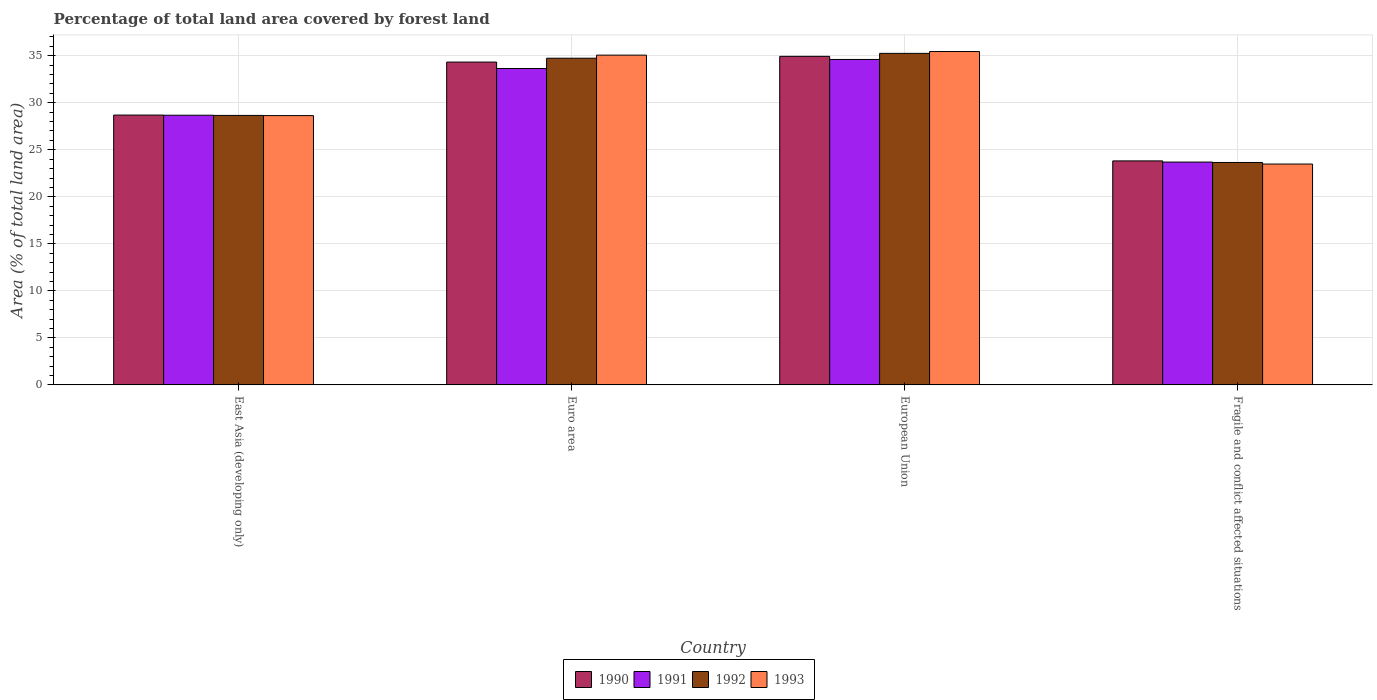How many different coloured bars are there?
Give a very brief answer. 4. Are the number of bars on each tick of the X-axis equal?
Make the answer very short. Yes. How many bars are there on the 3rd tick from the left?
Keep it short and to the point. 4. What is the label of the 3rd group of bars from the left?
Keep it short and to the point. European Union. What is the percentage of forest land in 1991 in European Union?
Make the answer very short. 34.6. Across all countries, what is the maximum percentage of forest land in 1993?
Keep it short and to the point. 35.45. Across all countries, what is the minimum percentage of forest land in 1993?
Provide a short and direct response. 23.48. In which country was the percentage of forest land in 1992 maximum?
Provide a succinct answer. European Union. In which country was the percentage of forest land in 1990 minimum?
Offer a very short reply. Fragile and conflict affected situations. What is the total percentage of forest land in 1990 in the graph?
Offer a very short reply. 121.77. What is the difference between the percentage of forest land in 1990 in East Asia (developing only) and that in European Union?
Offer a terse response. -6.24. What is the difference between the percentage of forest land in 1993 in Fragile and conflict affected situations and the percentage of forest land in 1992 in European Union?
Keep it short and to the point. -11.77. What is the average percentage of forest land in 1991 per country?
Keep it short and to the point. 30.15. What is the difference between the percentage of forest land of/in 1993 and percentage of forest land of/in 1992 in Fragile and conflict affected situations?
Ensure brevity in your answer.  -0.17. In how many countries, is the percentage of forest land in 1992 greater than 31 %?
Provide a succinct answer. 2. What is the ratio of the percentage of forest land in 1990 in East Asia (developing only) to that in Euro area?
Offer a very short reply. 0.84. Is the percentage of forest land in 1993 in Euro area less than that in Fragile and conflict affected situations?
Your response must be concise. No. What is the difference between the highest and the second highest percentage of forest land in 1990?
Offer a very short reply. 0.61. What is the difference between the highest and the lowest percentage of forest land in 1990?
Your answer should be compact. 11.12. What does the 4th bar from the left in European Union represents?
Provide a short and direct response. 1993. Are all the bars in the graph horizontal?
Offer a terse response. No. What is the difference between two consecutive major ticks on the Y-axis?
Provide a short and direct response. 5. Are the values on the major ticks of Y-axis written in scientific E-notation?
Keep it short and to the point. No. Does the graph contain any zero values?
Provide a short and direct response. No. Does the graph contain grids?
Your response must be concise. Yes. How are the legend labels stacked?
Provide a short and direct response. Horizontal. What is the title of the graph?
Provide a short and direct response. Percentage of total land area covered by forest land. Does "2001" appear as one of the legend labels in the graph?
Your response must be concise. No. What is the label or title of the Y-axis?
Give a very brief answer. Area (% of total land area). What is the Area (% of total land area) in 1990 in East Asia (developing only)?
Your answer should be compact. 28.69. What is the Area (% of total land area) of 1991 in East Asia (developing only)?
Offer a very short reply. 28.68. What is the Area (% of total land area) of 1992 in East Asia (developing only)?
Offer a very short reply. 28.65. What is the Area (% of total land area) of 1993 in East Asia (developing only)?
Offer a very short reply. 28.63. What is the Area (% of total land area) in 1990 in Euro area?
Offer a terse response. 34.33. What is the Area (% of total land area) in 1991 in Euro area?
Your answer should be very brief. 33.64. What is the Area (% of total land area) of 1992 in Euro area?
Keep it short and to the point. 34.74. What is the Area (% of total land area) in 1993 in Euro area?
Your answer should be very brief. 35.06. What is the Area (% of total land area) in 1990 in European Union?
Your answer should be very brief. 34.93. What is the Area (% of total land area) in 1991 in European Union?
Keep it short and to the point. 34.6. What is the Area (% of total land area) of 1992 in European Union?
Your answer should be compact. 35.25. What is the Area (% of total land area) of 1993 in European Union?
Your response must be concise. 35.45. What is the Area (% of total land area) in 1990 in Fragile and conflict affected situations?
Keep it short and to the point. 23.82. What is the Area (% of total land area) of 1991 in Fragile and conflict affected situations?
Offer a very short reply. 23.69. What is the Area (% of total land area) of 1992 in Fragile and conflict affected situations?
Your answer should be compact. 23.65. What is the Area (% of total land area) of 1993 in Fragile and conflict affected situations?
Provide a succinct answer. 23.48. Across all countries, what is the maximum Area (% of total land area) in 1990?
Your answer should be very brief. 34.93. Across all countries, what is the maximum Area (% of total land area) in 1991?
Provide a short and direct response. 34.6. Across all countries, what is the maximum Area (% of total land area) of 1992?
Your answer should be compact. 35.25. Across all countries, what is the maximum Area (% of total land area) of 1993?
Keep it short and to the point. 35.45. Across all countries, what is the minimum Area (% of total land area) in 1990?
Keep it short and to the point. 23.82. Across all countries, what is the minimum Area (% of total land area) in 1991?
Keep it short and to the point. 23.69. Across all countries, what is the minimum Area (% of total land area) of 1992?
Make the answer very short. 23.65. Across all countries, what is the minimum Area (% of total land area) of 1993?
Make the answer very short. 23.48. What is the total Area (% of total land area) of 1990 in the graph?
Ensure brevity in your answer.  121.77. What is the total Area (% of total land area) of 1991 in the graph?
Give a very brief answer. 120.62. What is the total Area (% of total land area) of 1992 in the graph?
Ensure brevity in your answer.  122.29. What is the total Area (% of total land area) in 1993 in the graph?
Your answer should be very brief. 122.63. What is the difference between the Area (% of total land area) in 1990 in East Asia (developing only) and that in Euro area?
Ensure brevity in your answer.  -5.63. What is the difference between the Area (% of total land area) of 1991 in East Asia (developing only) and that in Euro area?
Your answer should be very brief. -4.97. What is the difference between the Area (% of total land area) in 1992 in East Asia (developing only) and that in Euro area?
Make the answer very short. -6.08. What is the difference between the Area (% of total land area) of 1993 in East Asia (developing only) and that in Euro area?
Offer a terse response. -6.43. What is the difference between the Area (% of total land area) of 1990 in East Asia (developing only) and that in European Union?
Your answer should be very brief. -6.24. What is the difference between the Area (% of total land area) of 1991 in East Asia (developing only) and that in European Union?
Make the answer very short. -5.93. What is the difference between the Area (% of total land area) in 1992 in East Asia (developing only) and that in European Union?
Provide a short and direct response. -6.6. What is the difference between the Area (% of total land area) of 1993 in East Asia (developing only) and that in European Union?
Your answer should be very brief. -6.81. What is the difference between the Area (% of total land area) in 1990 in East Asia (developing only) and that in Fragile and conflict affected situations?
Your answer should be compact. 4.87. What is the difference between the Area (% of total land area) in 1991 in East Asia (developing only) and that in Fragile and conflict affected situations?
Give a very brief answer. 4.98. What is the difference between the Area (% of total land area) of 1992 in East Asia (developing only) and that in Fragile and conflict affected situations?
Your answer should be very brief. 5. What is the difference between the Area (% of total land area) of 1993 in East Asia (developing only) and that in Fragile and conflict affected situations?
Provide a short and direct response. 5.15. What is the difference between the Area (% of total land area) in 1990 in Euro area and that in European Union?
Provide a short and direct response. -0.61. What is the difference between the Area (% of total land area) of 1991 in Euro area and that in European Union?
Make the answer very short. -0.96. What is the difference between the Area (% of total land area) of 1992 in Euro area and that in European Union?
Give a very brief answer. -0.51. What is the difference between the Area (% of total land area) in 1993 in Euro area and that in European Union?
Offer a very short reply. -0.38. What is the difference between the Area (% of total land area) in 1990 in Euro area and that in Fragile and conflict affected situations?
Keep it short and to the point. 10.51. What is the difference between the Area (% of total land area) in 1991 in Euro area and that in Fragile and conflict affected situations?
Your answer should be compact. 9.95. What is the difference between the Area (% of total land area) in 1992 in Euro area and that in Fragile and conflict affected situations?
Offer a terse response. 11.09. What is the difference between the Area (% of total land area) of 1993 in Euro area and that in Fragile and conflict affected situations?
Your answer should be very brief. 11.58. What is the difference between the Area (% of total land area) in 1990 in European Union and that in Fragile and conflict affected situations?
Make the answer very short. 11.12. What is the difference between the Area (% of total land area) of 1991 in European Union and that in Fragile and conflict affected situations?
Ensure brevity in your answer.  10.91. What is the difference between the Area (% of total land area) in 1992 in European Union and that in Fragile and conflict affected situations?
Offer a very short reply. 11.6. What is the difference between the Area (% of total land area) of 1993 in European Union and that in Fragile and conflict affected situations?
Offer a very short reply. 11.96. What is the difference between the Area (% of total land area) in 1990 in East Asia (developing only) and the Area (% of total land area) in 1991 in Euro area?
Keep it short and to the point. -4.95. What is the difference between the Area (% of total land area) of 1990 in East Asia (developing only) and the Area (% of total land area) of 1992 in Euro area?
Your response must be concise. -6.05. What is the difference between the Area (% of total land area) in 1990 in East Asia (developing only) and the Area (% of total land area) in 1993 in Euro area?
Provide a succinct answer. -6.37. What is the difference between the Area (% of total land area) in 1991 in East Asia (developing only) and the Area (% of total land area) in 1992 in Euro area?
Your answer should be very brief. -6.06. What is the difference between the Area (% of total land area) of 1991 in East Asia (developing only) and the Area (% of total land area) of 1993 in Euro area?
Offer a very short reply. -6.39. What is the difference between the Area (% of total land area) of 1992 in East Asia (developing only) and the Area (% of total land area) of 1993 in Euro area?
Give a very brief answer. -6.41. What is the difference between the Area (% of total land area) of 1990 in East Asia (developing only) and the Area (% of total land area) of 1991 in European Union?
Provide a short and direct response. -5.91. What is the difference between the Area (% of total land area) of 1990 in East Asia (developing only) and the Area (% of total land area) of 1992 in European Union?
Offer a very short reply. -6.56. What is the difference between the Area (% of total land area) in 1990 in East Asia (developing only) and the Area (% of total land area) in 1993 in European Union?
Ensure brevity in your answer.  -6.75. What is the difference between the Area (% of total land area) of 1991 in East Asia (developing only) and the Area (% of total land area) of 1992 in European Union?
Offer a terse response. -6.58. What is the difference between the Area (% of total land area) of 1991 in East Asia (developing only) and the Area (% of total land area) of 1993 in European Union?
Give a very brief answer. -6.77. What is the difference between the Area (% of total land area) of 1992 in East Asia (developing only) and the Area (% of total land area) of 1993 in European Union?
Your answer should be very brief. -6.79. What is the difference between the Area (% of total land area) of 1990 in East Asia (developing only) and the Area (% of total land area) of 1991 in Fragile and conflict affected situations?
Offer a terse response. 5. What is the difference between the Area (% of total land area) in 1990 in East Asia (developing only) and the Area (% of total land area) in 1992 in Fragile and conflict affected situations?
Offer a terse response. 5.04. What is the difference between the Area (% of total land area) in 1990 in East Asia (developing only) and the Area (% of total land area) in 1993 in Fragile and conflict affected situations?
Offer a very short reply. 5.21. What is the difference between the Area (% of total land area) in 1991 in East Asia (developing only) and the Area (% of total land area) in 1992 in Fragile and conflict affected situations?
Your response must be concise. 5.02. What is the difference between the Area (% of total land area) of 1991 in East Asia (developing only) and the Area (% of total land area) of 1993 in Fragile and conflict affected situations?
Make the answer very short. 5.19. What is the difference between the Area (% of total land area) of 1992 in East Asia (developing only) and the Area (% of total land area) of 1993 in Fragile and conflict affected situations?
Your answer should be compact. 5.17. What is the difference between the Area (% of total land area) of 1990 in Euro area and the Area (% of total land area) of 1991 in European Union?
Keep it short and to the point. -0.28. What is the difference between the Area (% of total land area) of 1990 in Euro area and the Area (% of total land area) of 1992 in European Union?
Provide a succinct answer. -0.93. What is the difference between the Area (% of total land area) in 1990 in Euro area and the Area (% of total land area) in 1993 in European Union?
Ensure brevity in your answer.  -1.12. What is the difference between the Area (% of total land area) of 1991 in Euro area and the Area (% of total land area) of 1992 in European Union?
Offer a terse response. -1.61. What is the difference between the Area (% of total land area) in 1991 in Euro area and the Area (% of total land area) in 1993 in European Union?
Offer a very short reply. -1.8. What is the difference between the Area (% of total land area) of 1992 in Euro area and the Area (% of total land area) of 1993 in European Union?
Offer a terse response. -0.71. What is the difference between the Area (% of total land area) in 1990 in Euro area and the Area (% of total land area) in 1991 in Fragile and conflict affected situations?
Give a very brief answer. 10.63. What is the difference between the Area (% of total land area) in 1990 in Euro area and the Area (% of total land area) in 1992 in Fragile and conflict affected situations?
Your answer should be compact. 10.68. What is the difference between the Area (% of total land area) of 1990 in Euro area and the Area (% of total land area) of 1993 in Fragile and conflict affected situations?
Your response must be concise. 10.84. What is the difference between the Area (% of total land area) of 1991 in Euro area and the Area (% of total land area) of 1992 in Fragile and conflict affected situations?
Ensure brevity in your answer.  9.99. What is the difference between the Area (% of total land area) in 1991 in Euro area and the Area (% of total land area) in 1993 in Fragile and conflict affected situations?
Your response must be concise. 10.16. What is the difference between the Area (% of total land area) of 1992 in Euro area and the Area (% of total land area) of 1993 in Fragile and conflict affected situations?
Offer a very short reply. 11.25. What is the difference between the Area (% of total land area) in 1990 in European Union and the Area (% of total land area) in 1991 in Fragile and conflict affected situations?
Offer a very short reply. 11.24. What is the difference between the Area (% of total land area) of 1990 in European Union and the Area (% of total land area) of 1992 in Fragile and conflict affected situations?
Provide a short and direct response. 11.28. What is the difference between the Area (% of total land area) of 1990 in European Union and the Area (% of total land area) of 1993 in Fragile and conflict affected situations?
Give a very brief answer. 11.45. What is the difference between the Area (% of total land area) of 1991 in European Union and the Area (% of total land area) of 1992 in Fragile and conflict affected situations?
Offer a very short reply. 10.95. What is the difference between the Area (% of total land area) of 1991 in European Union and the Area (% of total land area) of 1993 in Fragile and conflict affected situations?
Provide a succinct answer. 11.12. What is the difference between the Area (% of total land area) of 1992 in European Union and the Area (% of total land area) of 1993 in Fragile and conflict affected situations?
Your answer should be very brief. 11.77. What is the average Area (% of total land area) of 1990 per country?
Keep it short and to the point. 30.44. What is the average Area (% of total land area) of 1991 per country?
Your response must be concise. 30.15. What is the average Area (% of total land area) in 1992 per country?
Your answer should be compact. 30.57. What is the average Area (% of total land area) of 1993 per country?
Ensure brevity in your answer.  30.66. What is the difference between the Area (% of total land area) of 1990 and Area (% of total land area) of 1991 in East Asia (developing only)?
Ensure brevity in your answer.  0.02. What is the difference between the Area (% of total land area) of 1990 and Area (% of total land area) of 1992 in East Asia (developing only)?
Keep it short and to the point. 0.04. What is the difference between the Area (% of total land area) in 1990 and Area (% of total land area) in 1993 in East Asia (developing only)?
Ensure brevity in your answer.  0.06. What is the difference between the Area (% of total land area) in 1991 and Area (% of total land area) in 1992 in East Asia (developing only)?
Your answer should be very brief. 0.02. What is the difference between the Area (% of total land area) of 1991 and Area (% of total land area) of 1993 in East Asia (developing only)?
Provide a short and direct response. 0.04. What is the difference between the Area (% of total land area) in 1992 and Area (% of total land area) in 1993 in East Asia (developing only)?
Make the answer very short. 0.02. What is the difference between the Area (% of total land area) of 1990 and Area (% of total land area) of 1991 in Euro area?
Provide a short and direct response. 0.68. What is the difference between the Area (% of total land area) in 1990 and Area (% of total land area) in 1992 in Euro area?
Give a very brief answer. -0.41. What is the difference between the Area (% of total land area) in 1990 and Area (% of total land area) in 1993 in Euro area?
Ensure brevity in your answer.  -0.74. What is the difference between the Area (% of total land area) of 1991 and Area (% of total land area) of 1992 in Euro area?
Give a very brief answer. -1.09. What is the difference between the Area (% of total land area) of 1991 and Area (% of total land area) of 1993 in Euro area?
Ensure brevity in your answer.  -1.42. What is the difference between the Area (% of total land area) of 1992 and Area (% of total land area) of 1993 in Euro area?
Provide a short and direct response. -0.33. What is the difference between the Area (% of total land area) of 1990 and Area (% of total land area) of 1991 in European Union?
Offer a terse response. 0.33. What is the difference between the Area (% of total land area) in 1990 and Area (% of total land area) in 1992 in European Union?
Ensure brevity in your answer.  -0.32. What is the difference between the Area (% of total land area) in 1990 and Area (% of total land area) in 1993 in European Union?
Keep it short and to the point. -0.51. What is the difference between the Area (% of total land area) in 1991 and Area (% of total land area) in 1992 in European Union?
Provide a succinct answer. -0.65. What is the difference between the Area (% of total land area) of 1991 and Area (% of total land area) of 1993 in European Union?
Your answer should be compact. -0.84. What is the difference between the Area (% of total land area) of 1992 and Area (% of total land area) of 1993 in European Union?
Make the answer very short. -0.19. What is the difference between the Area (% of total land area) in 1990 and Area (% of total land area) in 1991 in Fragile and conflict affected situations?
Provide a short and direct response. 0.12. What is the difference between the Area (% of total land area) of 1990 and Area (% of total land area) of 1992 in Fragile and conflict affected situations?
Keep it short and to the point. 0.17. What is the difference between the Area (% of total land area) in 1990 and Area (% of total land area) in 1993 in Fragile and conflict affected situations?
Provide a succinct answer. 0.33. What is the difference between the Area (% of total land area) in 1991 and Area (% of total land area) in 1992 in Fragile and conflict affected situations?
Provide a succinct answer. 0.04. What is the difference between the Area (% of total land area) of 1991 and Area (% of total land area) of 1993 in Fragile and conflict affected situations?
Your answer should be compact. 0.21. What is the difference between the Area (% of total land area) in 1992 and Area (% of total land area) in 1993 in Fragile and conflict affected situations?
Make the answer very short. 0.17. What is the ratio of the Area (% of total land area) in 1990 in East Asia (developing only) to that in Euro area?
Offer a very short reply. 0.84. What is the ratio of the Area (% of total land area) in 1991 in East Asia (developing only) to that in Euro area?
Your answer should be compact. 0.85. What is the ratio of the Area (% of total land area) of 1992 in East Asia (developing only) to that in Euro area?
Make the answer very short. 0.82. What is the ratio of the Area (% of total land area) in 1993 in East Asia (developing only) to that in Euro area?
Keep it short and to the point. 0.82. What is the ratio of the Area (% of total land area) in 1990 in East Asia (developing only) to that in European Union?
Provide a short and direct response. 0.82. What is the ratio of the Area (% of total land area) of 1991 in East Asia (developing only) to that in European Union?
Provide a succinct answer. 0.83. What is the ratio of the Area (% of total land area) of 1992 in East Asia (developing only) to that in European Union?
Offer a terse response. 0.81. What is the ratio of the Area (% of total land area) of 1993 in East Asia (developing only) to that in European Union?
Ensure brevity in your answer.  0.81. What is the ratio of the Area (% of total land area) in 1990 in East Asia (developing only) to that in Fragile and conflict affected situations?
Provide a short and direct response. 1.2. What is the ratio of the Area (% of total land area) of 1991 in East Asia (developing only) to that in Fragile and conflict affected situations?
Keep it short and to the point. 1.21. What is the ratio of the Area (% of total land area) in 1992 in East Asia (developing only) to that in Fragile and conflict affected situations?
Your response must be concise. 1.21. What is the ratio of the Area (% of total land area) of 1993 in East Asia (developing only) to that in Fragile and conflict affected situations?
Give a very brief answer. 1.22. What is the ratio of the Area (% of total land area) of 1990 in Euro area to that in European Union?
Your response must be concise. 0.98. What is the ratio of the Area (% of total land area) in 1991 in Euro area to that in European Union?
Offer a very short reply. 0.97. What is the ratio of the Area (% of total land area) of 1992 in Euro area to that in European Union?
Ensure brevity in your answer.  0.99. What is the ratio of the Area (% of total land area) in 1990 in Euro area to that in Fragile and conflict affected situations?
Make the answer very short. 1.44. What is the ratio of the Area (% of total land area) of 1991 in Euro area to that in Fragile and conflict affected situations?
Provide a short and direct response. 1.42. What is the ratio of the Area (% of total land area) in 1992 in Euro area to that in Fragile and conflict affected situations?
Your answer should be compact. 1.47. What is the ratio of the Area (% of total land area) of 1993 in Euro area to that in Fragile and conflict affected situations?
Ensure brevity in your answer.  1.49. What is the ratio of the Area (% of total land area) in 1990 in European Union to that in Fragile and conflict affected situations?
Give a very brief answer. 1.47. What is the ratio of the Area (% of total land area) in 1991 in European Union to that in Fragile and conflict affected situations?
Provide a succinct answer. 1.46. What is the ratio of the Area (% of total land area) of 1992 in European Union to that in Fragile and conflict affected situations?
Your answer should be compact. 1.49. What is the ratio of the Area (% of total land area) in 1993 in European Union to that in Fragile and conflict affected situations?
Make the answer very short. 1.51. What is the difference between the highest and the second highest Area (% of total land area) of 1990?
Offer a very short reply. 0.61. What is the difference between the highest and the second highest Area (% of total land area) of 1991?
Provide a succinct answer. 0.96. What is the difference between the highest and the second highest Area (% of total land area) of 1992?
Your answer should be very brief. 0.51. What is the difference between the highest and the second highest Area (% of total land area) in 1993?
Ensure brevity in your answer.  0.38. What is the difference between the highest and the lowest Area (% of total land area) in 1990?
Offer a very short reply. 11.12. What is the difference between the highest and the lowest Area (% of total land area) of 1991?
Your response must be concise. 10.91. What is the difference between the highest and the lowest Area (% of total land area) in 1992?
Your response must be concise. 11.6. What is the difference between the highest and the lowest Area (% of total land area) in 1993?
Offer a very short reply. 11.96. 